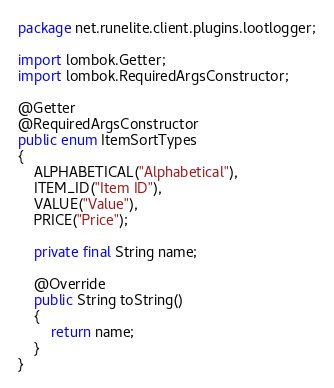<code> <loc_0><loc_0><loc_500><loc_500><_Java_>package net.runelite.client.plugins.lootlogger;

import lombok.Getter;
import lombok.RequiredArgsConstructor;

@Getter
@RequiredArgsConstructor
public enum ItemSortTypes
{
	ALPHABETICAL("Alphabetical"),
	ITEM_ID("Item ID"),
	VALUE("Value"),
	PRICE("Price");

	private final String name;

	@Override
	public String toString()
	{
		return name;
	}
}
</code> 